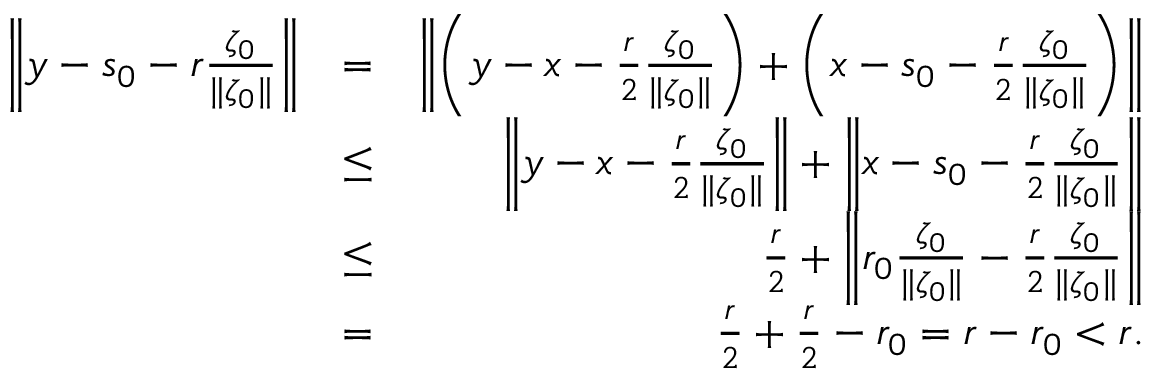<formula> <loc_0><loc_0><loc_500><loc_500>\begin{array} { r l r } { \left \| y - s _ { 0 } - r \frac { \zeta _ { 0 } } { \| \zeta _ { 0 } \| } \right \| } & { = } & { \left \| \left ( y - x - \frac { r } { 2 } \frac { \zeta _ { 0 } } { \| \zeta _ { 0 } \| } \right ) + \left ( x - s _ { 0 } - \frac { r } { 2 } \frac { \zeta _ { 0 } } { \| \zeta _ { 0 } \| } \right ) \right \| } \\ & { \leq } & { \left \| y - x - \frac { r } { 2 } \frac { \zeta _ { 0 } } { \| \zeta _ { 0 } \| } \right \| + \left \| x - s _ { 0 } - \frac { r } { 2 } \frac { \zeta _ { 0 } } { \| \zeta _ { 0 } \| } \right \| } \\ & { \leq } & { \frac { r } { 2 } + \left \| r _ { 0 } \frac { \zeta _ { 0 } } { \| \zeta _ { 0 } \| } - \frac { r } { 2 } \frac { \zeta _ { 0 } } { \| \zeta _ { 0 } \| } \right \| } \\ & { = } & { \frac { r } { 2 } + \frac { r } { 2 } - r _ { 0 } = r - r _ { 0 } < r . } \end{array}</formula> 